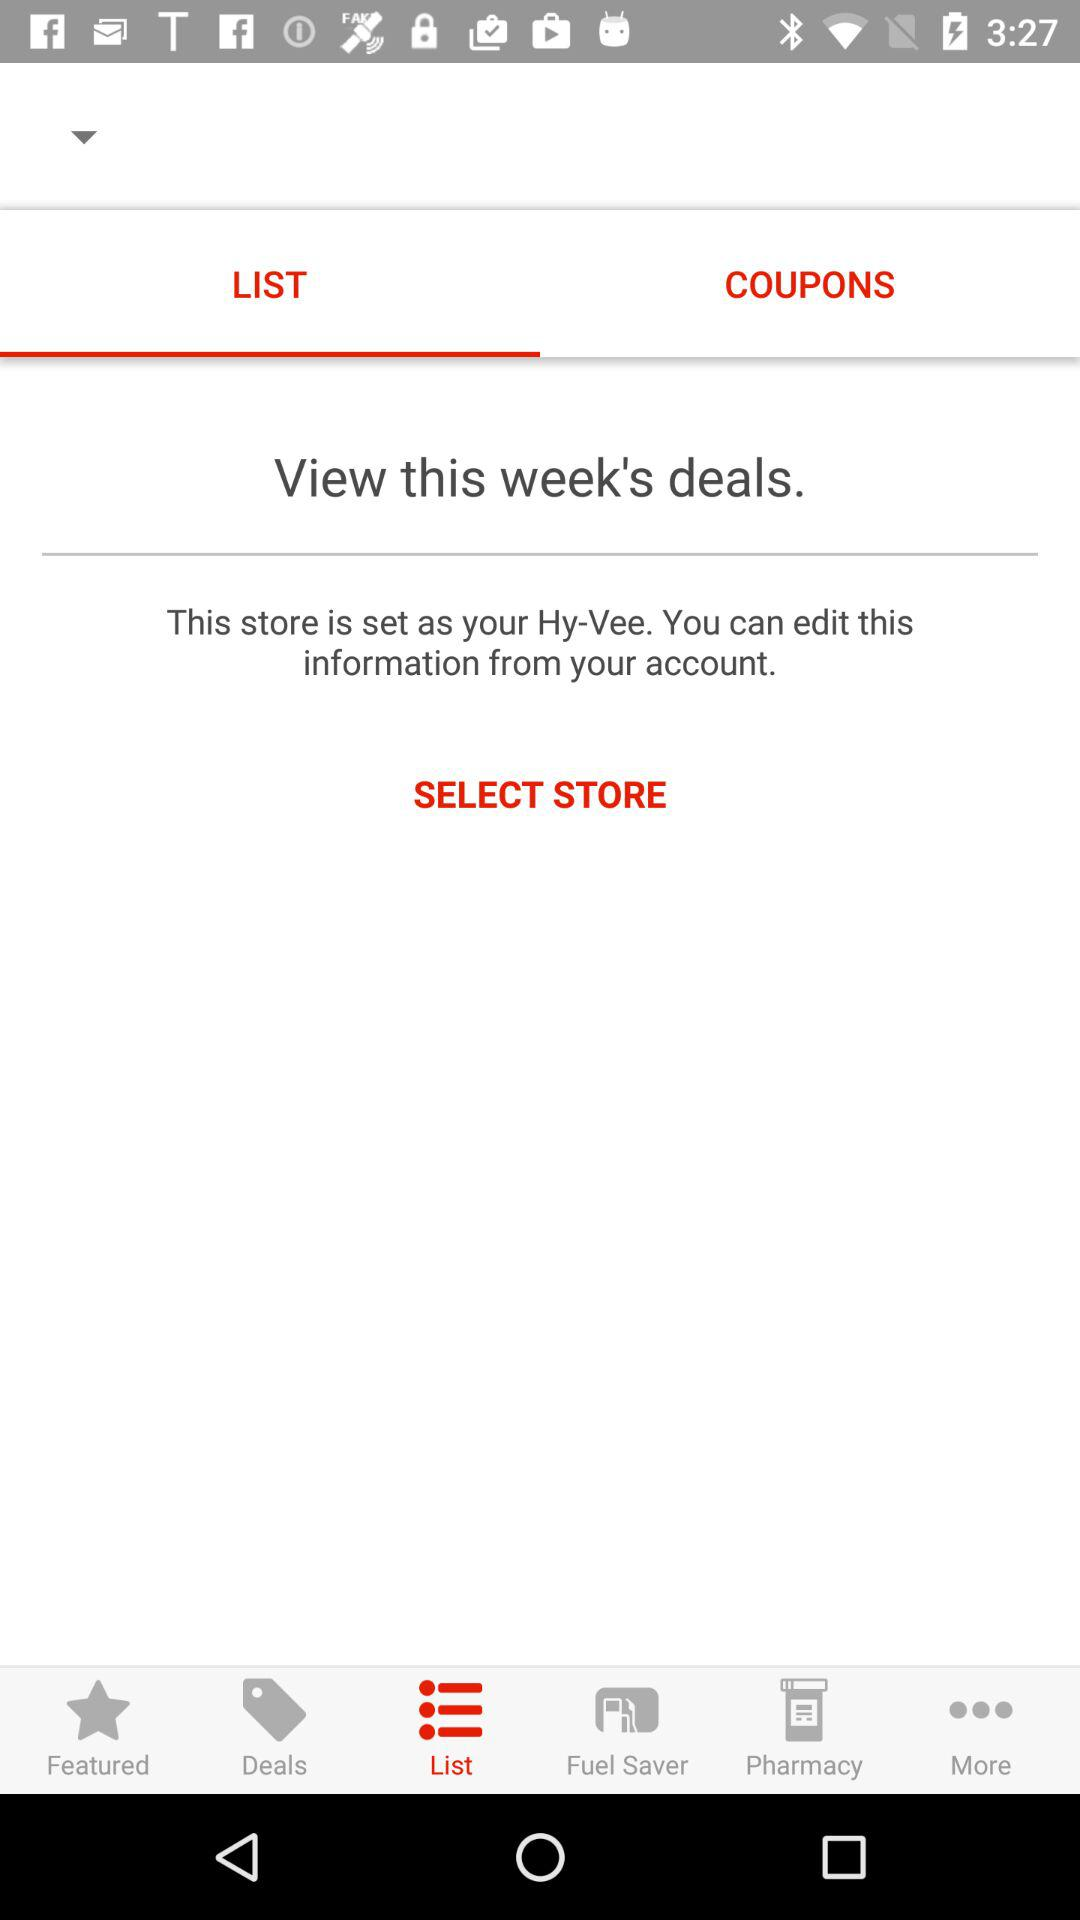What's the selected tab? The selected tab is List. 